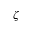<formula> <loc_0><loc_0><loc_500><loc_500>\zeta</formula> 